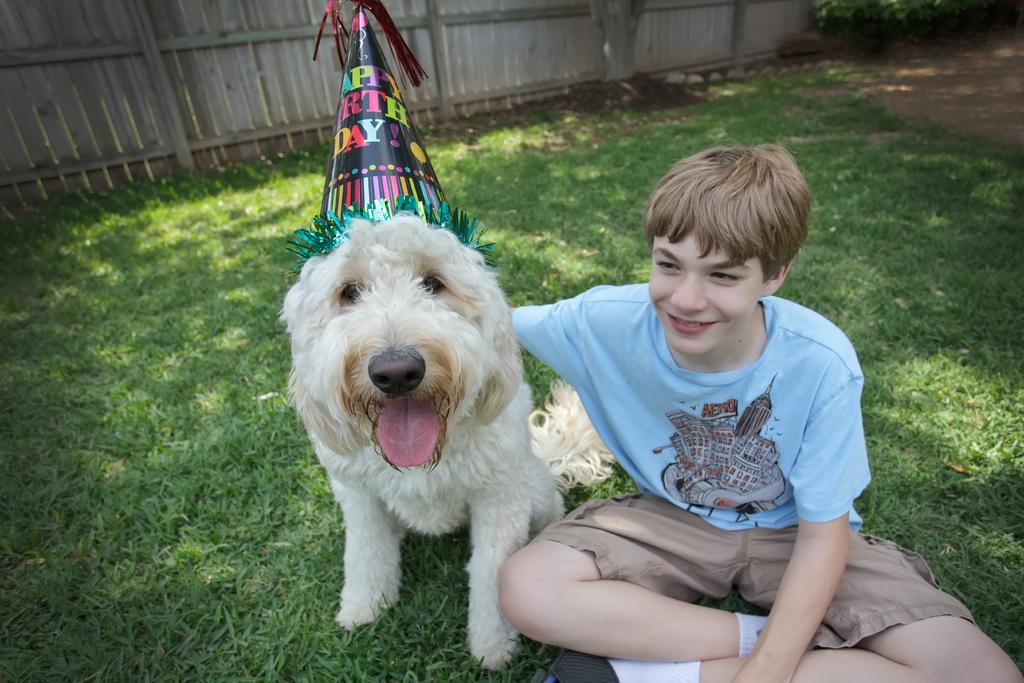What is the main subject of the image? There is a person in the image. What is the person doing in the image? The person is sitting on the grass. Are there any animals in the image? Yes, there is a dog in the image. What type of appliance is the person using to pet the dog in the image? There is no appliance present in the image, and the person is not using any appliance to pet the dog. 